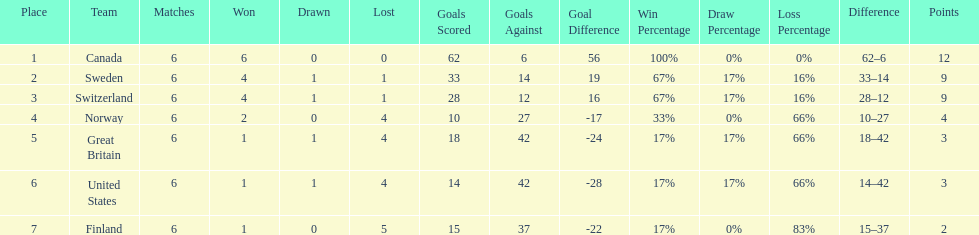Which team won more matches, finland or norway? Norway. I'm looking to parse the entire table for insights. Could you assist me with that? {'header': ['Place', 'Team', 'Matches', 'Won', 'Drawn', 'Lost', 'Goals Scored', 'Goals Against', 'Goal Difference', 'Win Percentage', 'Draw Percentage', 'Loss Percentage', 'Difference', 'Points'], 'rows': [['1', 'Canada', '6', '6', '0', '0', '62', '6', '56', '100%', '0%', '0%', '62–6', '12'], ['2', 'Sweden', '6', '4', '1', '1', '33', '14', '19', '67%', '17%', '16%', '33–14', '9'], ['3', 'Switzerland', '6', '4', '1', '1', '28', '12', '16', '67%', '17%', '16%', '28–12', '9'], ['4', 'Norway', '6', '2', '0', '4', '10', '27', '-17', '33%', '0%', '66%', '10–27', '4'], ['5', 'Great Britain', '6', '1', '1', '4', '18', '42', '-24', '17%', '17%', '66%', '18–42', '3'], ['6', 'United States', '6', '1', '1', '4', '14', '42', '-28', '17%', '17%', '66%', '14–42', '3'], ['7', 'Finland', '6', '1', '0', '5', '15', '37', '-22', '17%', '0%', '83%', '15–37', '2']]} 